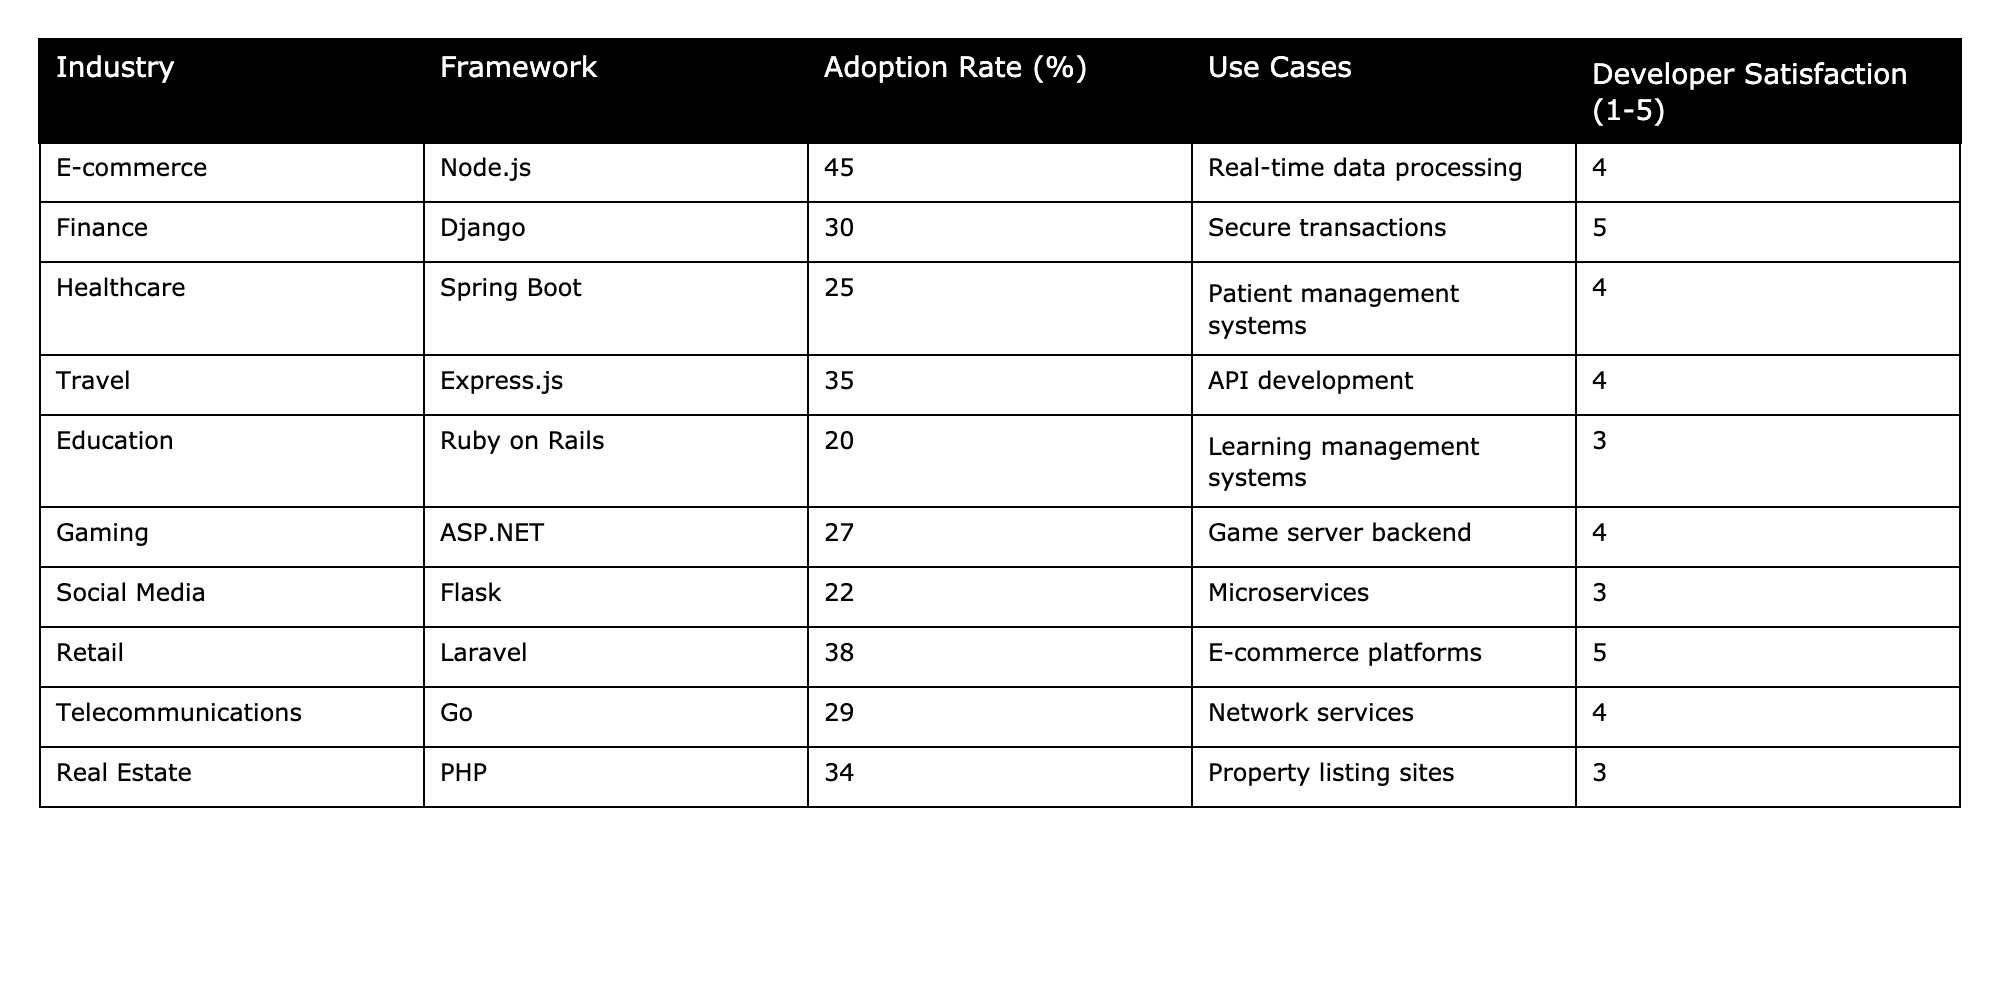What is the adoption rate of Node.js in the e-commerce industry? The table shows that Node.js has an adoption rate of 45% in the e-commerce industry.
Answer: 45% Which framework has the highest developer satisfaction score? The table displays developer satisfaction scores, with Django scoring the highest at 5.
Answer: Django What is the average adoption rate across all frameworks listed? The adoption rates are 45, 30, 25, 35, 20, 27, 22, 38, 29, and 34. Summing these gives  45 + 30 + 25 + 35 + 20 + 27 + 22 + 38 + 29 + 34 = 359. Dividing by the number of frameworks (10) gives an average of 35.9.
Answer: 35.9% Is it true that Ruby on Rails is mainly used for e-commerce platforms? The table indicates that Ruby on Rails is used for learning management systems, not specifically for e-commerce platforms.
Answer: False What is the difference in adoption rates between the frameworks with the highest and lowest adoption rates? The highest adoption rate is 45% (Node.js) and the lowest is 20% (Ruby on Rails). The difference is 45 - 20 = 25.
Answer: 25% Which industry has the lowest developer satisfaction? Referring to the table, Ruby on Rails in the education industry has the lowest developer satisfaction score of 3.
Answer: Education How many frameworks have an adoption rate above 30%? The frameworks with adoption rates above 30% are Node.js (45%), Express.js (35%), Laravel (38%), and Real Estate (34%)—totaling four frameworks.
Answer: 4 What is the total developer satisfaction score for all industries listed? The developer satisfaction scores are 4, 5, 4, 4, 3, 4, 3, 5, 4, 3. Summing these gives 4 + 5 + 4 + 4 + 3 + 4 + 3 + 5 + 4 + 3 = 43.
Answer: 43 